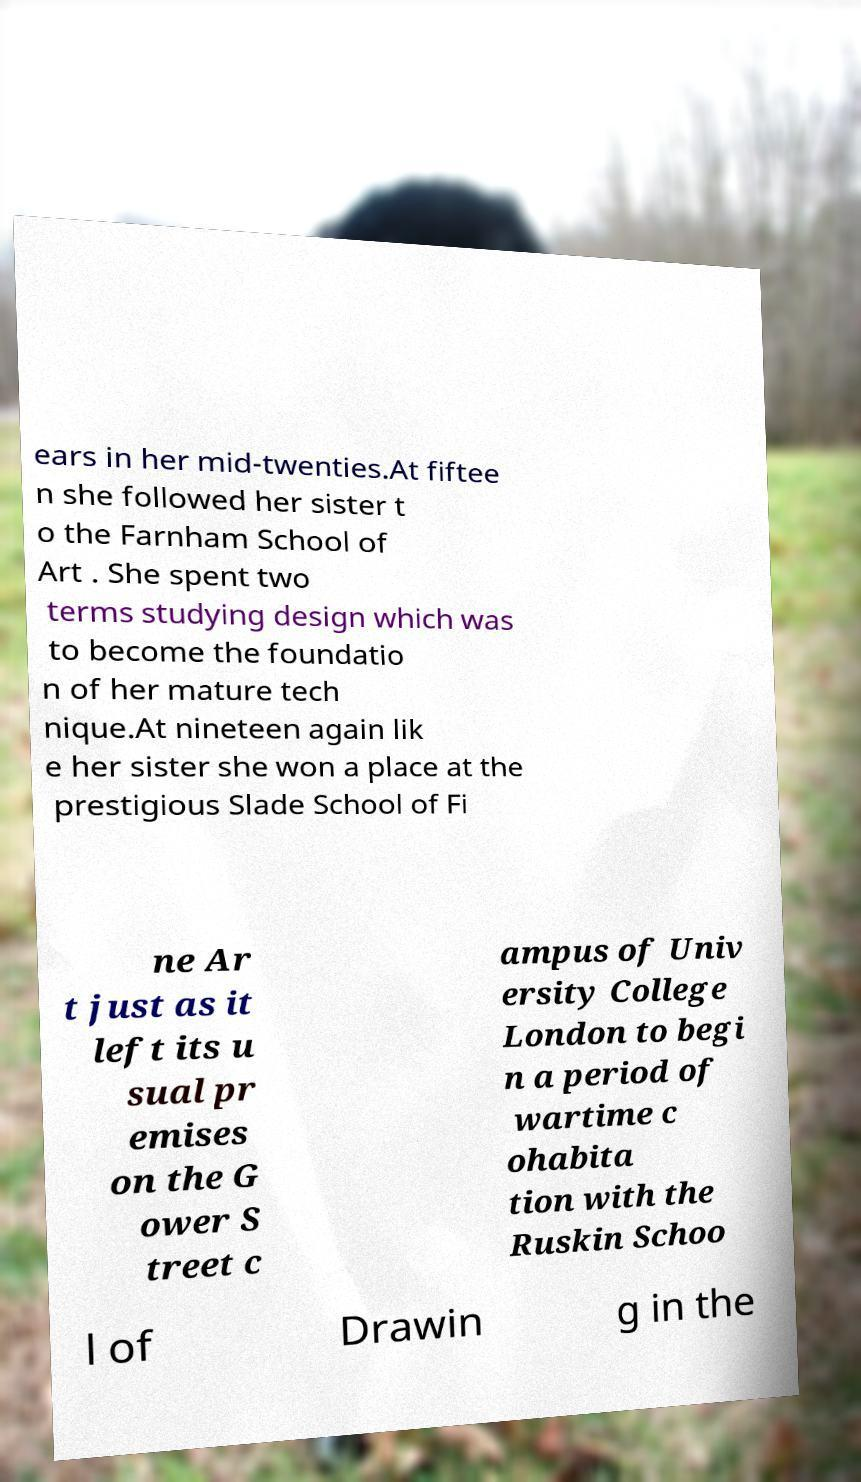Could you assist in decoding the text presented in this image and type it out clearly? ears in her mid-twenties.At fiftee n she followed her sister t o the Farnham School of Art . She spent two terms studying design which was to become the foundatio n of her mature tech nique.At nineteen again lik e her sister she won a place at the prestigious Slade School of Fi ne Ar t just as it left its u sual pr emises on the G ower S treet c ampus of Univ ersity College London to begi n a period of wartime c ohabita tion with the Ruskin Schoo l of Drawin g in the 